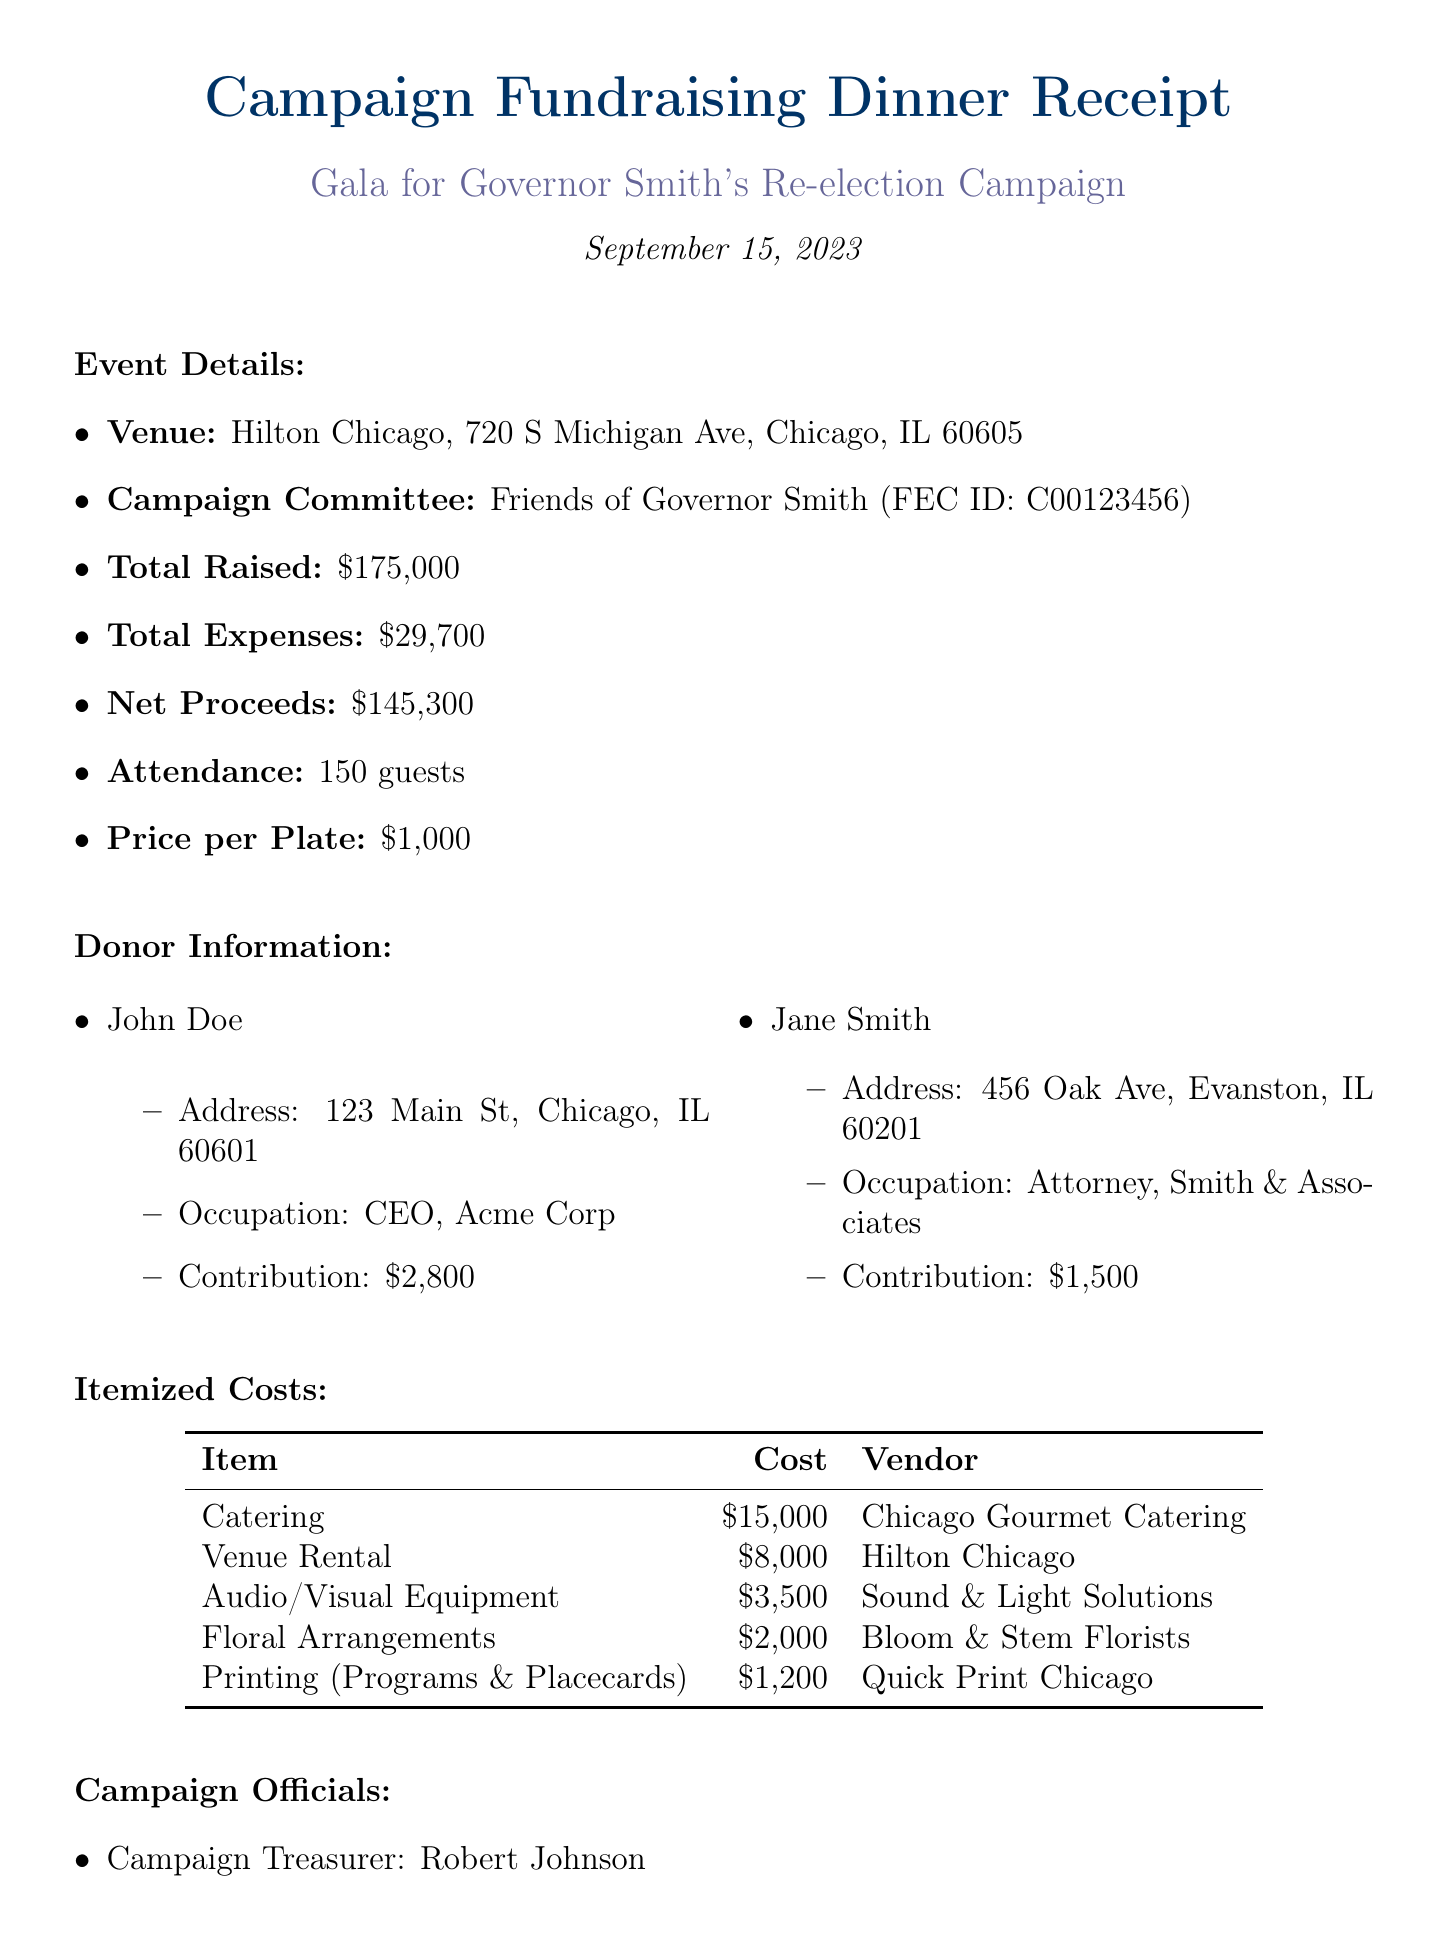What is the event name? The event name is explicitly stated at the beginning of the document under "Gala for Governor Smith's Re-election Campaign."
Answer: Gala for Governor Smith's Re-election Campaign What is the total raised amount? The total raised amount is clearly mentioned in the event details section of the document.
Answer: $175,000 Who is the campaign treasurer? The campaign treasurer's name is provided in the section for campaign officials within the document.
Answer: Robert Johnson How much did the catering cost? The itemized costs list the catering cost under the specific itemized entries.
Answer: $15,000 What is the date of the event? The event date is specified in the document under "September 15, 2023."
Answer: September 15, 2023 What is the net proceeds from the event? The net proceeds are calculated as total raised minus total expenses, provided in the document.
Answer: $145,300 Who are the guest speakers? The guest speakers are listed in a separate section of the document, with their names provided.
Answer: Senator Lisa Brown, Mayor Tom Wilson What was the price per plate? The price per plate is detailed in the event details section, giving a specific amount charged for each attendee.
Answer: $1,000 